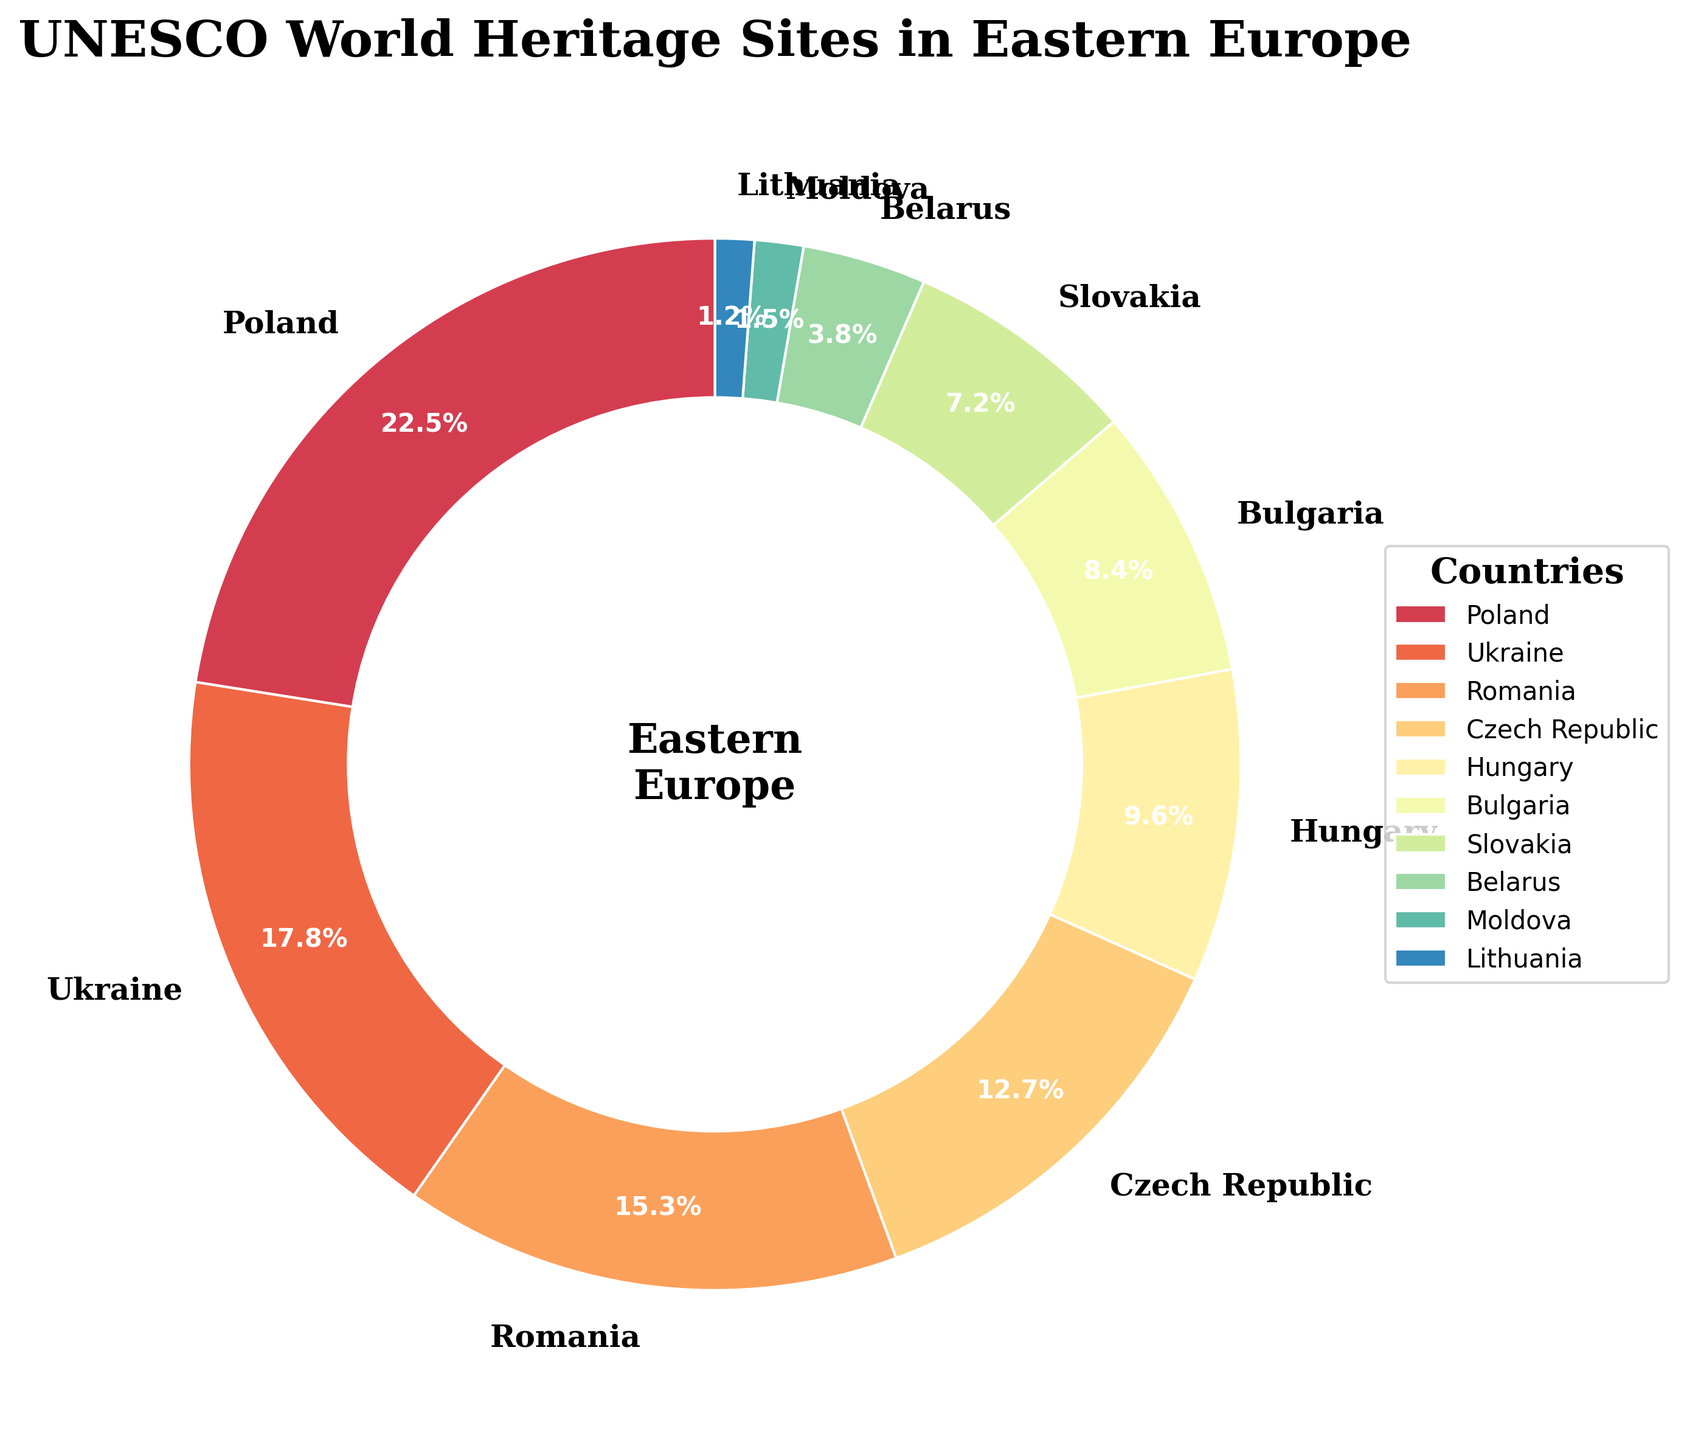Which country has the highest percentage of UNESCO World Heritage Sites in Eastern Europe? The largest wedge in the pie chart corresponds to Poland, which has the highest percentage, shown as 22.5%.
Answer: Poland What is the combined percentage of UNESCO World Heritage Sites in Ukraine and Romania? The pie chart shows Ukraine with 17.8% and Romania with 15.3%. Summing these up gives 17.8 + 15.3 = 33.1%.
Answer: 33.1% Which countries have a percentage of less than 10%? By observing the pie chart, it shows Hungary with 9.6%, Bulgaria with 8.4%, Slovakia with 7.2%, Belarus with 3.8%, Moldova with 1.5%, and Lithuania with 1.2%. All are less than 10%.
Answer: Hungary, Bulgaria, Slovakia, Belarus, Moldova, Lithuania How much more percentage does Poland have compared to Lithuania? Poland has 22.5% and Lithuania has 1.2%. To find the difference, subtract Lithuania's percentage from Poland's: 22.5 - 1.2 = 21.3%.
Answer: 21.3% What is the average percentage of UNESCO World Heritage Sites for Slovakia, Belarus, and Moldova? Slovakia has 7.2%, Belarus has 3.8%, and Moldova has 1.5%. To find the average, sum these percentages and divide by 3: (7.2 + 3.8 + 1.5) / 3 = 12.5 / 3 ≈ 4.17%.
Answer: 4.17% Which country has a slightly higher percentage than the Czech Republic? The pie chart shows the Czech Republic at 12.7% and Romania at 15.3%. No countries have a slightly higher percentage than 12.7%, only significantly different ones.
Answer: None Are there more UNESCO World Heritage Sites in Poland and Ukraine combined than in all the other countries combined? Poland and Ukraine together have 22.5% + 17.8% = 40.3%. Summing the percentages of the other countries: 15.3 + 12.7 + 9.6 + 8.4 + 7.2 + 3.8 + 1.5 + 1.2 = 59.7%. Since 40.3% < 59.7%, the answer is no.
Answer: No Which country appears closest to the center of the chart, spatially? The wedges are centered around the same point, so visually, they are all at an equal distance from the center, but the text "Eastern Europe" is in the very center.
Answer: All equally 